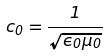Convert formula to latex. <formula><loc_0><loc_0><loc_500><loc_500>c _ { 0 } = \frac { 1 } { \sqrt { \epsilon _ { 0 } \mu _ { 0 } } }</formula> 